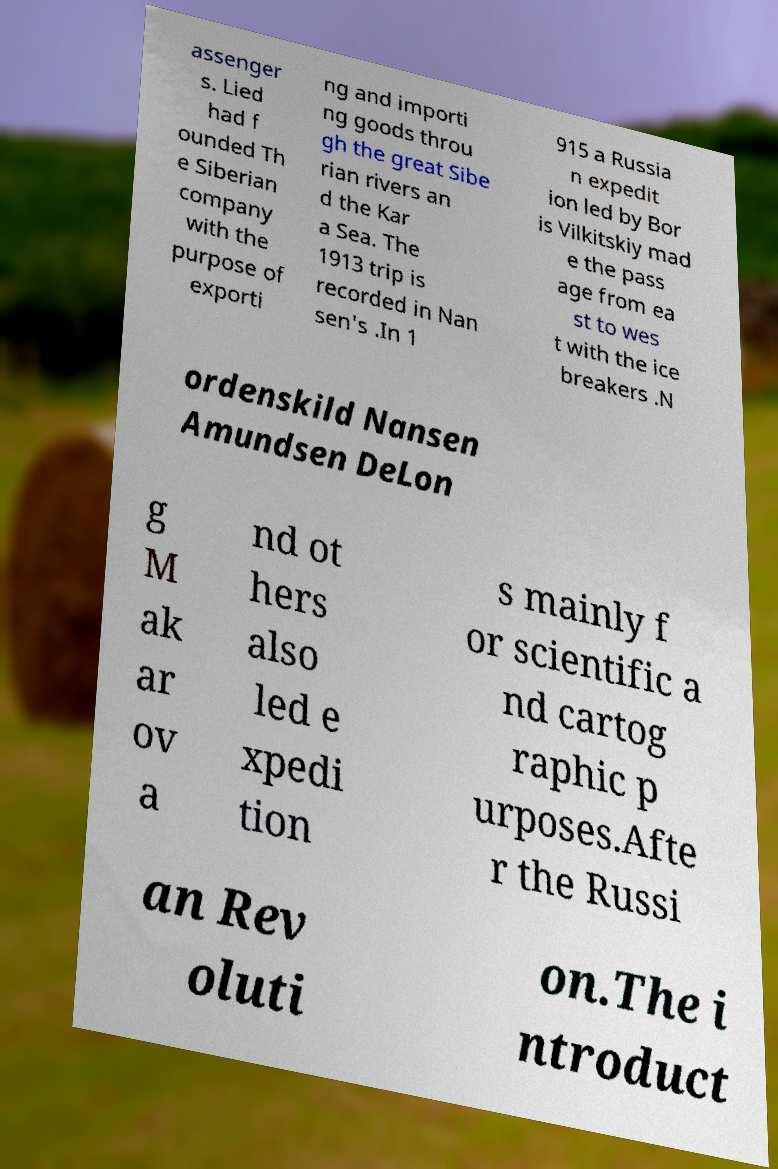Can you accurately transcribe the text from the provided image for me? assenger s. Lied had f ounded Th e Siberian company with the purpose of exporti ng and importi ng goods throu gh the great Sibe rian rivers an d the Kar a Sea. The 1913 trip is recorded in Nan sen's .In 1 915 a Russia n expedit ion led by Bor is Vilkitskiy mad e the pass age from ea st to wes t with the ice breakers .N ordenskild Nansen Amundsen DeLon g M ak ar ov a nd ot hers also led e xpedi tion s mainly f or scientific a nd cartog raphic p urposes.Afte r the Russi an Rev oluti on.The i ntroduct 